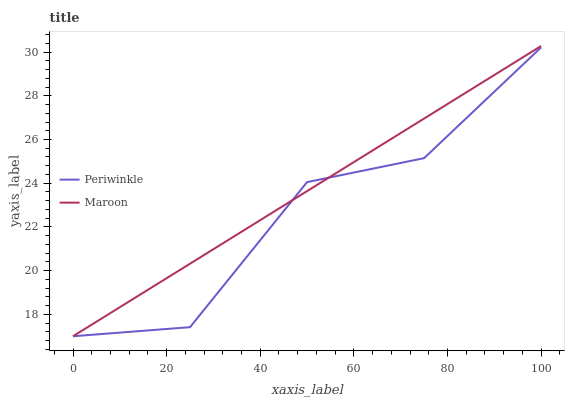Does Periwinkle have the minimum area under the curve?
Answer yes or no. Yes. Does Maroon have the maximum area under the curve?
Answer yes or no. Yes. Does Maroon have the minimum area under the curve?
Answer yes or no. No. Is Maroon the smoothest?
Answer yes or no. Yes. Is Periwinkle the roughest?
Answer yes or no. Yes. Is Maroon the roughest?
Answer yes or no. No. Does Periwinkle have the lowest value?
Answer yes or no. Yes. Does Maroon have the highest value?
Answer yes or no. Yes. Does Periwinkle intersect Maroon?
Answer yes or no. Yes. Is Periwinkle less than Maroon?
Answer yes or no. No. Is Periwinkle greater than Maroon?
Answer yes or no. No. 